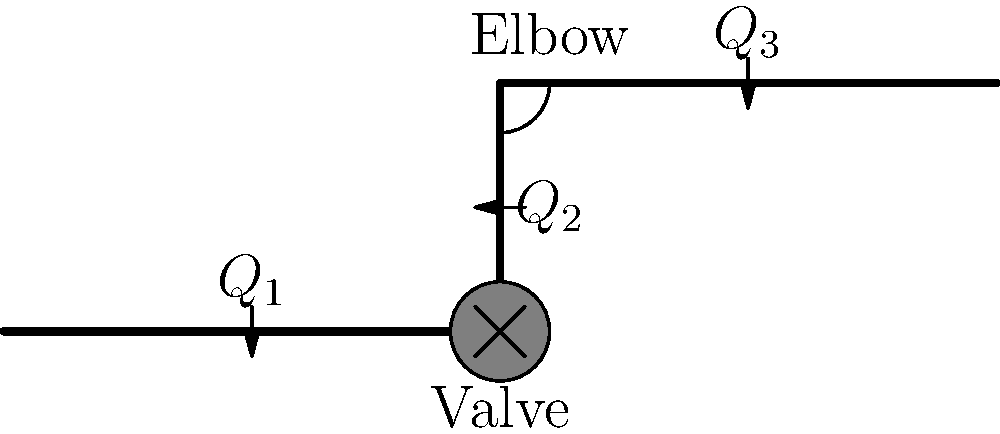In a piping system for a nonprofit organization's water distribution project, water flows through a straight pipe, then through a valve, up a vertical pipe, and finally through an elbow before reaching its destination. If the flow rate at the entrance of the straight pipe ($Q_1$) is 100 liters per minute, the valve causes a 20% reduction in flow rate, and the elbow causes an additional 10% reduction, what is the final flow rate ($Q_3$) in liters per minute? To solve this problem, we'll follow these steps:

1. Start with the initial flow rate:
   $Q_1 = 100$ liters per minute

2. Calculate the flow rate after the valve ($Q_2$):
   The valve causes a 20% reduction, so 80% of the flow passes through.
   $Q_2 = Q_1 \times 0.80 = 100 \times 0.80 = 80$ liters per minute

3. Calculate the final flow rate after the elbow ($Q_3$):
   The elbow causes an additional 10% reduction, so 90% of $Q_2$ passes through.
   $Q_3 = Q_2 \times 0.90 = 80 \times 0.90 = 72$ liters per minute

Therefore, the final flow rate ($Q_3$) after passing through the valve and elbow is 72 liters per minute.
Answer: 72 liters per minute 